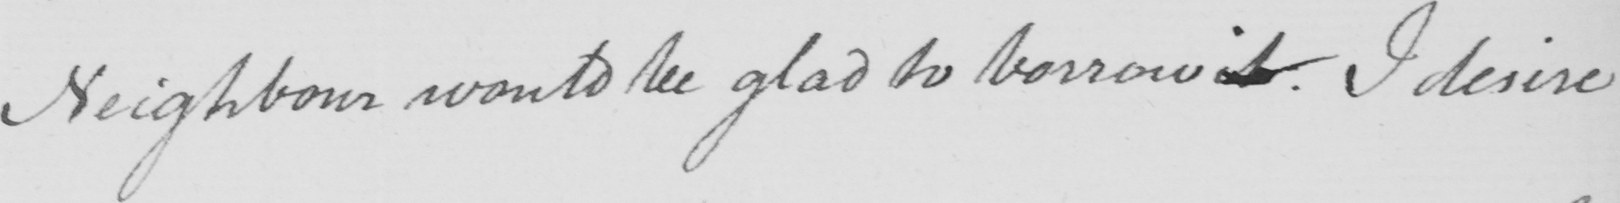Can you tell me what this handwritten text says? Neighbour would be glad to borrow it . I desire 